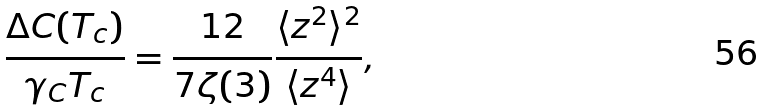<formula> <loc_0><loc_0><loc_500><loc_500>\frac { \Delta C ( T _ { c } ) } { \gamma _ { C } T _ { c } } = \frac { 1 2 } { 7 \zeta ( 3 ) } \frac { \langle z ^ { 2 } \rangle ^ { 2 } } { \langle z ^ { 4 } \rangle } ,</formula> 